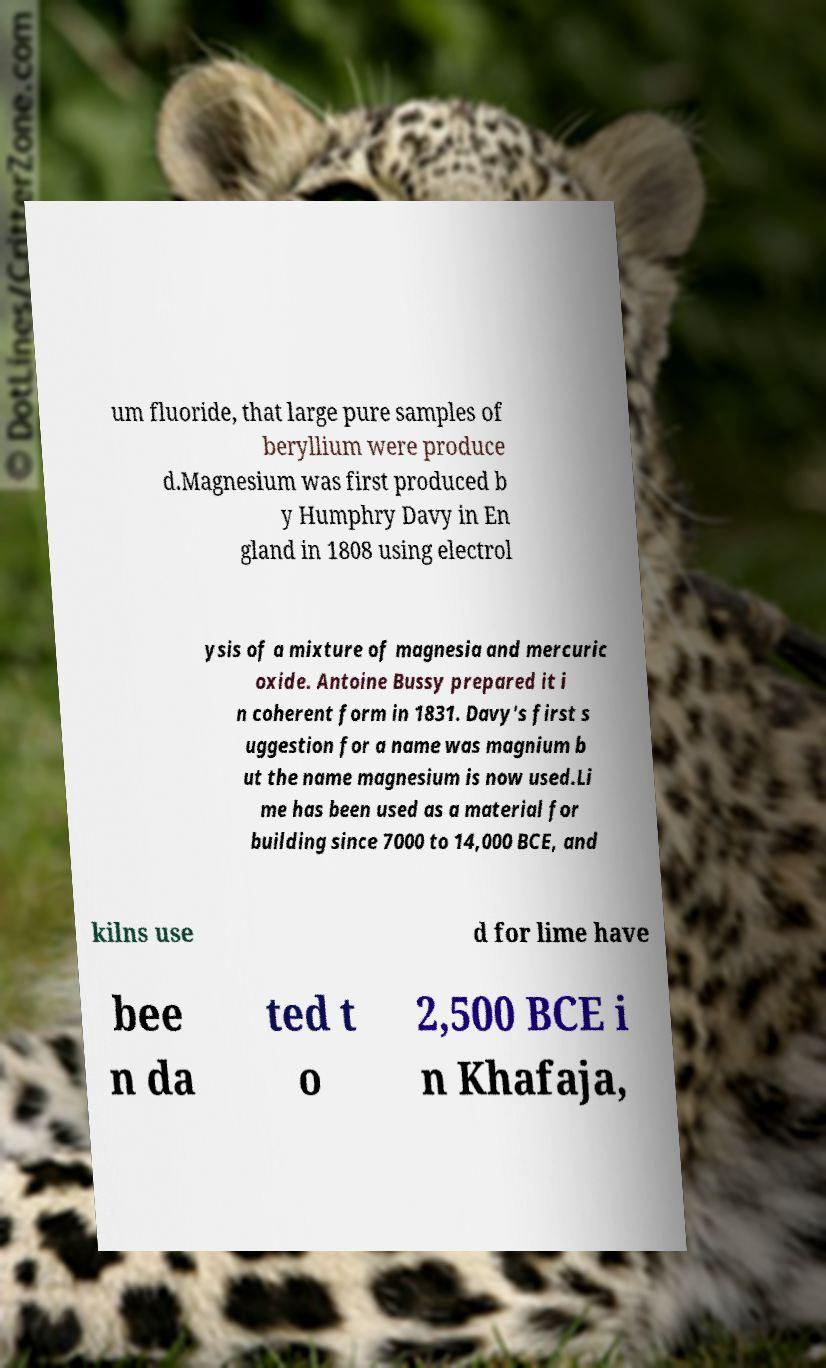I need the written content from this picture converted into text. Can you do that? um fluoride, that large pure samples of beryllium were produce d.Magnesium was first produced b y Humphry Davy in En gland in 1808 using electrol ysis of a mixture of magnesia and mercuric oxide. Antoine Bussy prepared it i n coherent form in 1831. Davy's first s uggestion for a name was magnium b ut the name magnesium is now used.Li me has been used as a material for building since 7000 to 14,000 BCE, and kilns use d for lime have bee n da ted t o 2,500 BCE i n Khafaja, 